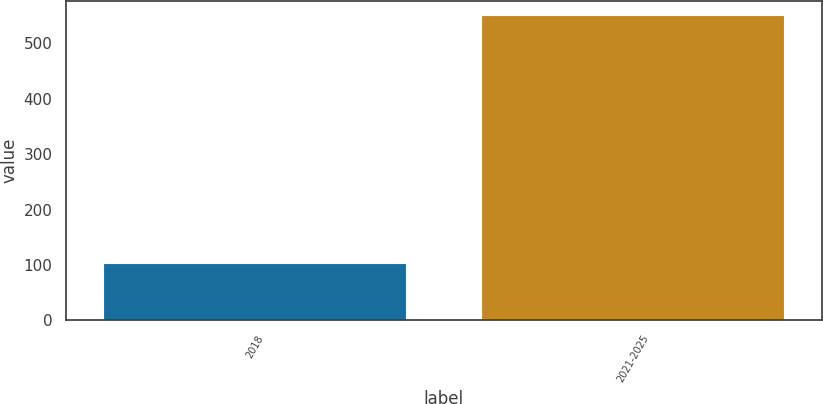Convert chart to OTSL. <chart><loc_0><loc_0><loc_500><loc_500><bar_chart><fcel>2018<fcel>2021-2025<nl><fcel>102<fcel>550<nl></chart> 